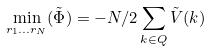<formula> <loc_0><loc_0><loc_500><loc_500>\min _ { r _ { 1 } \dots r _ { N } } ( \tilde { \Phi } ) = - N / 2 \sum _ { k \in Q } \tilde { V } ( k )</formula> 